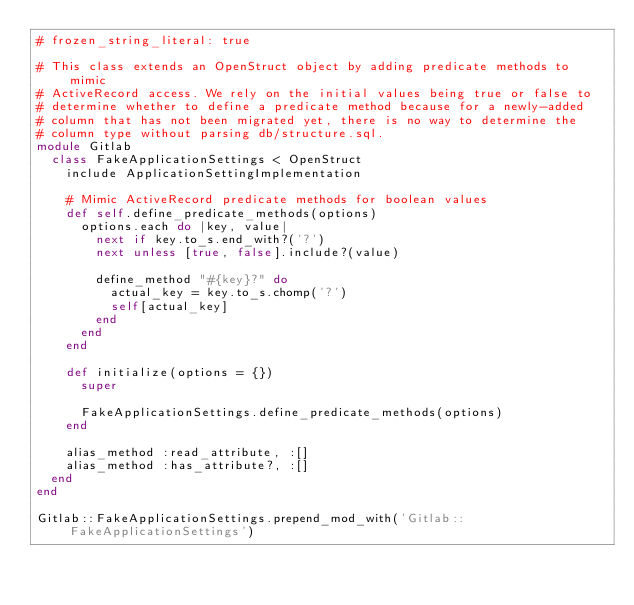Convert code to text. <code><loc_0><loc_0><loc_500><loc_500><_Ruby_># frozen_string_literal: true

# This class extends an OpenStruct object by adding predicate methods to mimic
# ActiveRecord access. We rely on the initial values being true or false to
# determine whether to define a predicate method because for a newly-added
# column that has not been migrated yet, there is no way to determine the
# column type without parsing db/structure.sql.
module Gitlab
  class FakeApplicationSettings < OpenStruct
    include ApplicationSettingImplementation

    # Mimic ActiveRecord predicate methods for boolean values
    def self.define_predicate_methods(options)
      options.each do |key, value|
        next if key.to_s.end_with?('?')
        next unless [true, false].include?(value)

        define_method "#{key}?" do
          actual_key = key.to_s.chomp('?')
          self[actual_key]
        end
      end
    end

    def initialize(options = {})
      super

      FakeApplicationSettings.define_predicate_methods(options)
    end

    alias_method :read_attribute, :[]
    alias_method :has_attribute?, :[]
  end
end

Gitlab::FakeApplicationSettings.prepend_mod_with('Gitlab::FakeApplicationSettings')
</code> 